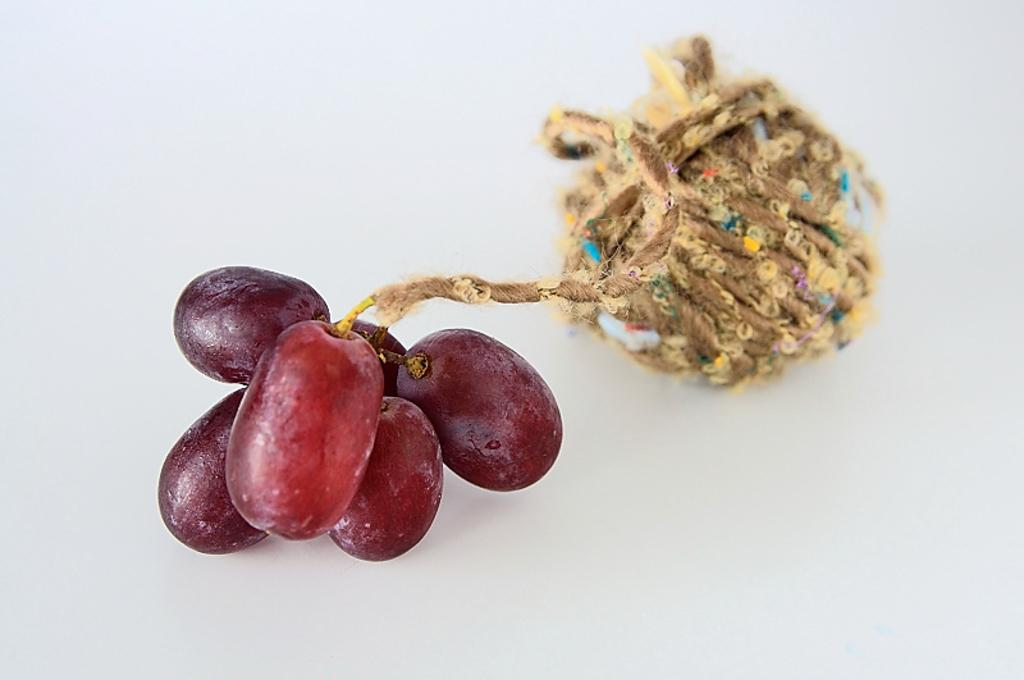What type of fruit can be seen in the image? There is a small bunch of grapes in the image. How are the grapes arranged or connected? The grapes are tied to a rope. What is the color of the background in the image? The background of the image is white in color. What type of soap is being used to clean the ant in the image? There is no soap, ant, or cleaning activity present in the image. 